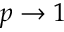<formula> <loc_0><loc_0><loc_500><loc_500>p \rightarrow 1</formula> 